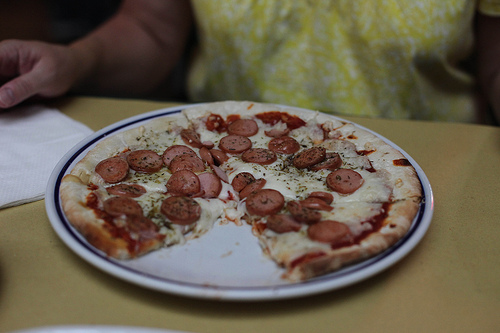<image>
Can you confirm if the food is on the table? Yes. Looking at the image, I can see the food is positioned on top of the table, with the table providing support. 